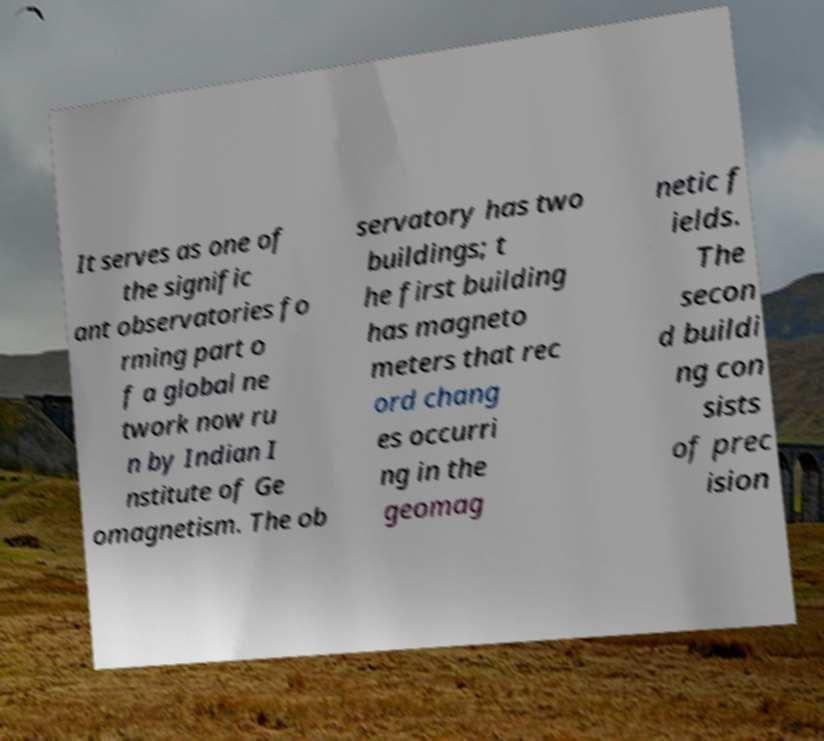What messages or text are displayed in this image? I need them in a readable, typed format. It serves as one of the signific ant observatories fo rming part o f a global ne twork now ru n by Indian I nstitute of Ge omagnetism. The ob servatory has two buildings; t he first building has magneto meters that rec ord chang es occurri ng in the geomag netic f ields. The secon d buildi ng con sists of prec ision 